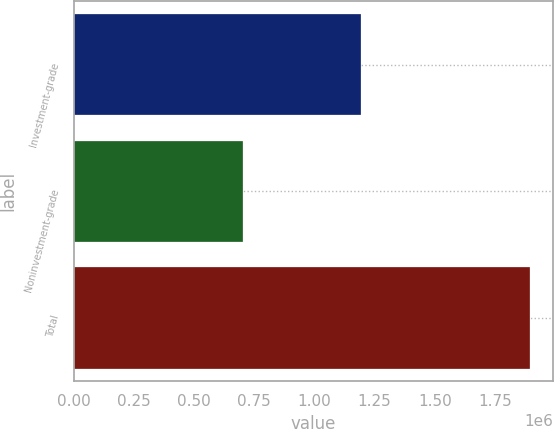<chart> <loc_0><loc_0><loc_500><loc_500><bar_chart><fcel>Investment-grade<fcel>Noninvestment-grade<fcel>Total<nl><fcel>1.1947e+06<fcel>702638<fcel>1.89733e+06<nl></chart> 